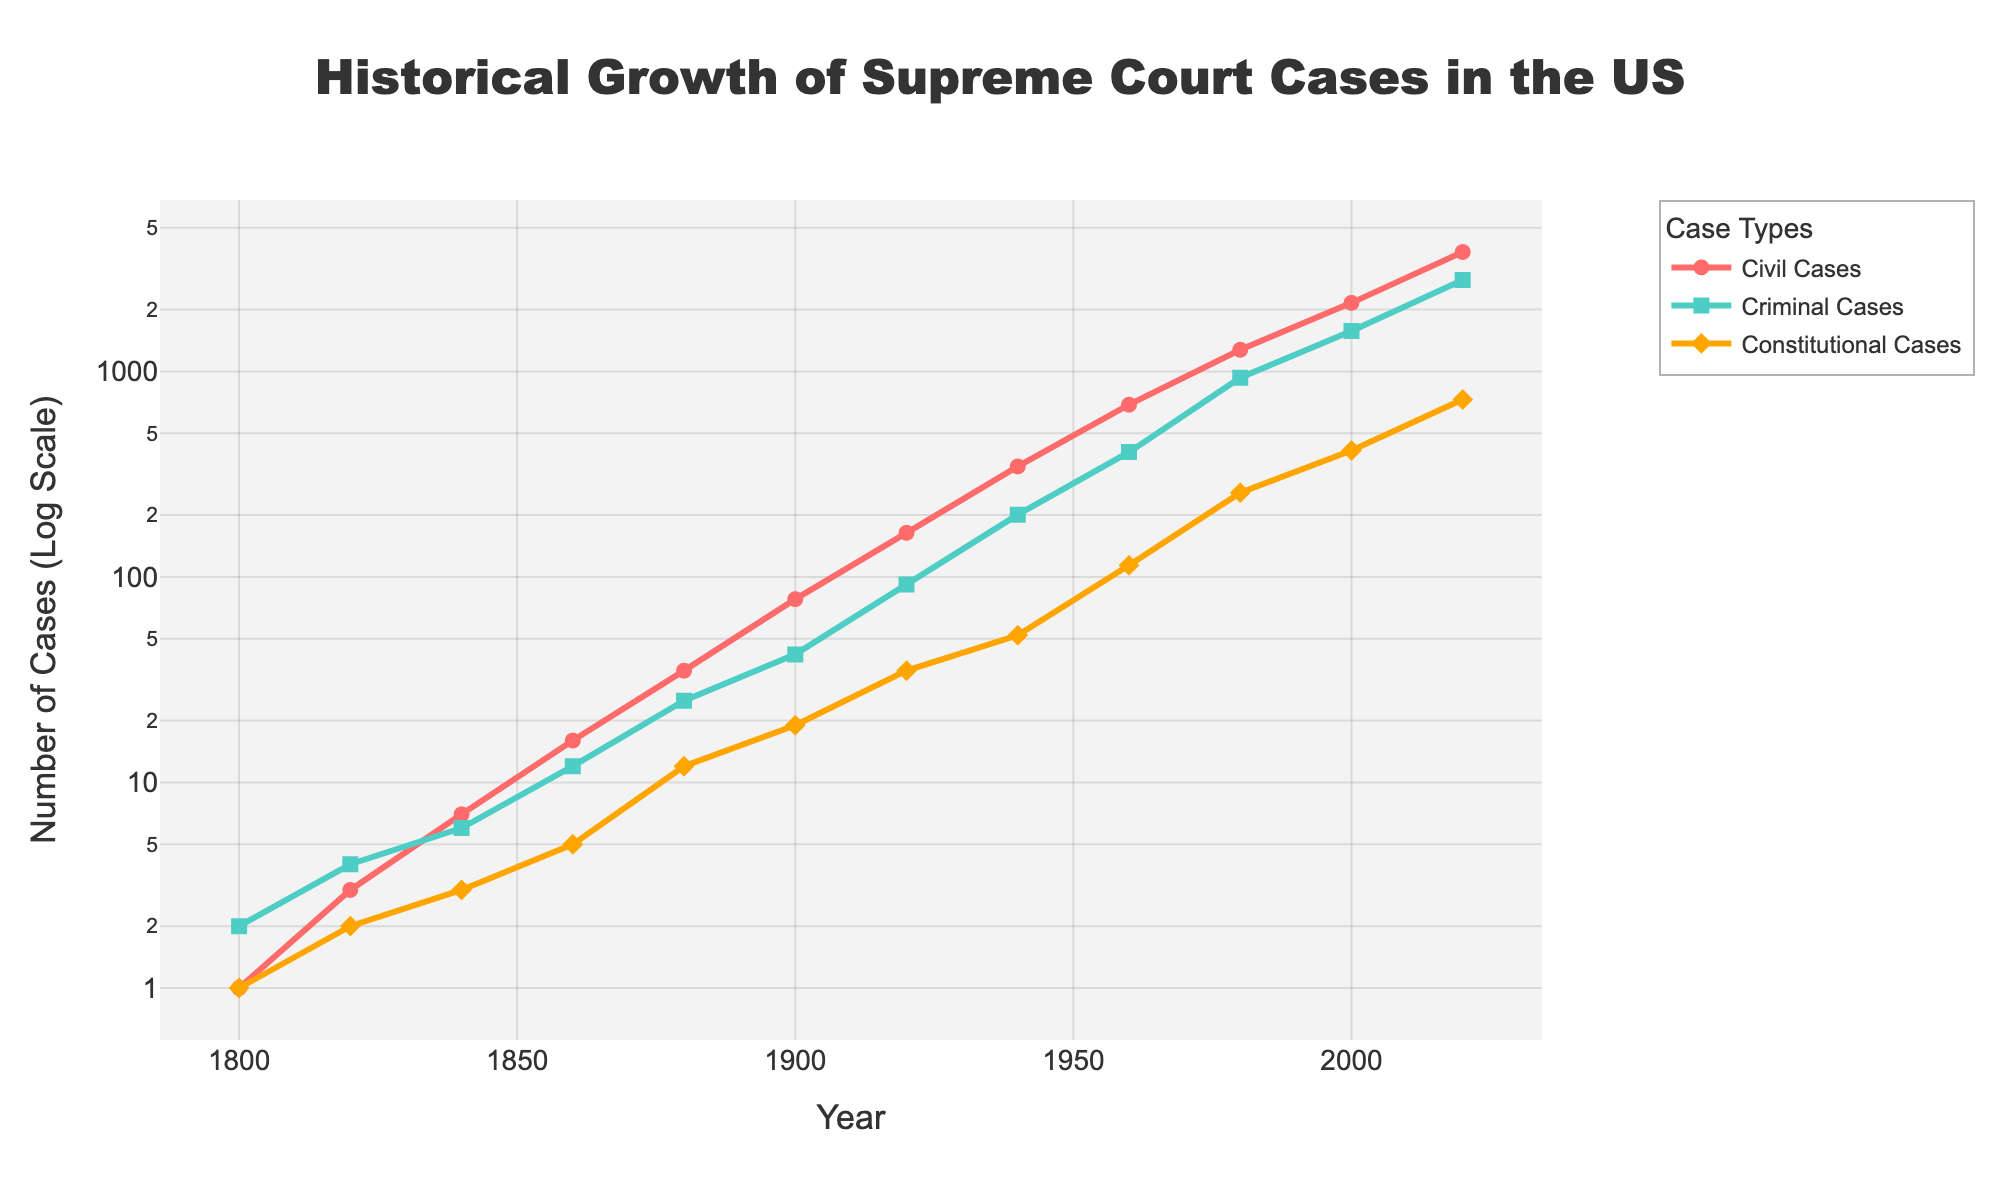what is the title of the figure? The title can be found at the top of the figure and states the overall subject of the data presented.
Answer: Historical Growth of Supreme Court Cases in the US How many case categories are represented in the plot? By observing the legend of the plot, we can see the different case categories denoted by their labels and colors.
Answer: Three Which case type had the most significant growth from 1800 to 2020? By comparing the end points of each line, we can see which category increased the most in terms of magnitude.
Answer: Civil Cases What year did the number of criminal cases surpass 1000? Locate the point on the Criminal Cases line where the y-value first exceeds 1000 and find the corresponding year on the x-axis.
Answer: 1980 How does the growth rate of constitutional cases compare to that of criminal cases between 1880 and 1920? Compare the slopes of the constitutional and criminal case lines between 1880 and 1920 to understand their growth rates. The slope of the criminal case line is steeper than that of the constitutional case line in this period.
Answer: Criminal cases grew faster What were the approximate number of civil cases in 1860? Look at the Civil Cases line and find the y-value corresponding to the x-value where the year is 1860.
Answer: 16 By what year did the number of civil cases first exceed 1000? Examine the Civil Cases line and find the year where it first crosses the 1000 mark on the y-axis.
Answer: 1980 Which category had the fewest cases in the year 1900? Compare the y-values for each category in the year 1900.
Answer: Constitutional Cases What is the general trend of all the case categories from 1800 to 2020? Observe the overall direction and shape of all lines from left to right to infer the general behavior over time. All three case types show exponential growth over time.
Answer: Exponential growth Calculate the ratio of civil cases to constitutional cases in 2020. Use the values given for civil and constitutional cases in 2020 and divide the civil cases by the constitutional cases. The values given are 3812 for civil and 730 for constitutional. Therefore, 3812/730 ≈ 5.22.
Answer: 5.22 